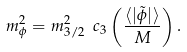<formula> <loc_0><loc_0><loc_500><loc_500>m _ { \phi } ^ { 2 } = m _ { 3 / 2 } ^ { 2 } \ c _ { 3 } \left ( \frac { \langle | \tilde { \phi } | \rangle } { M } \right ) .</formula> 